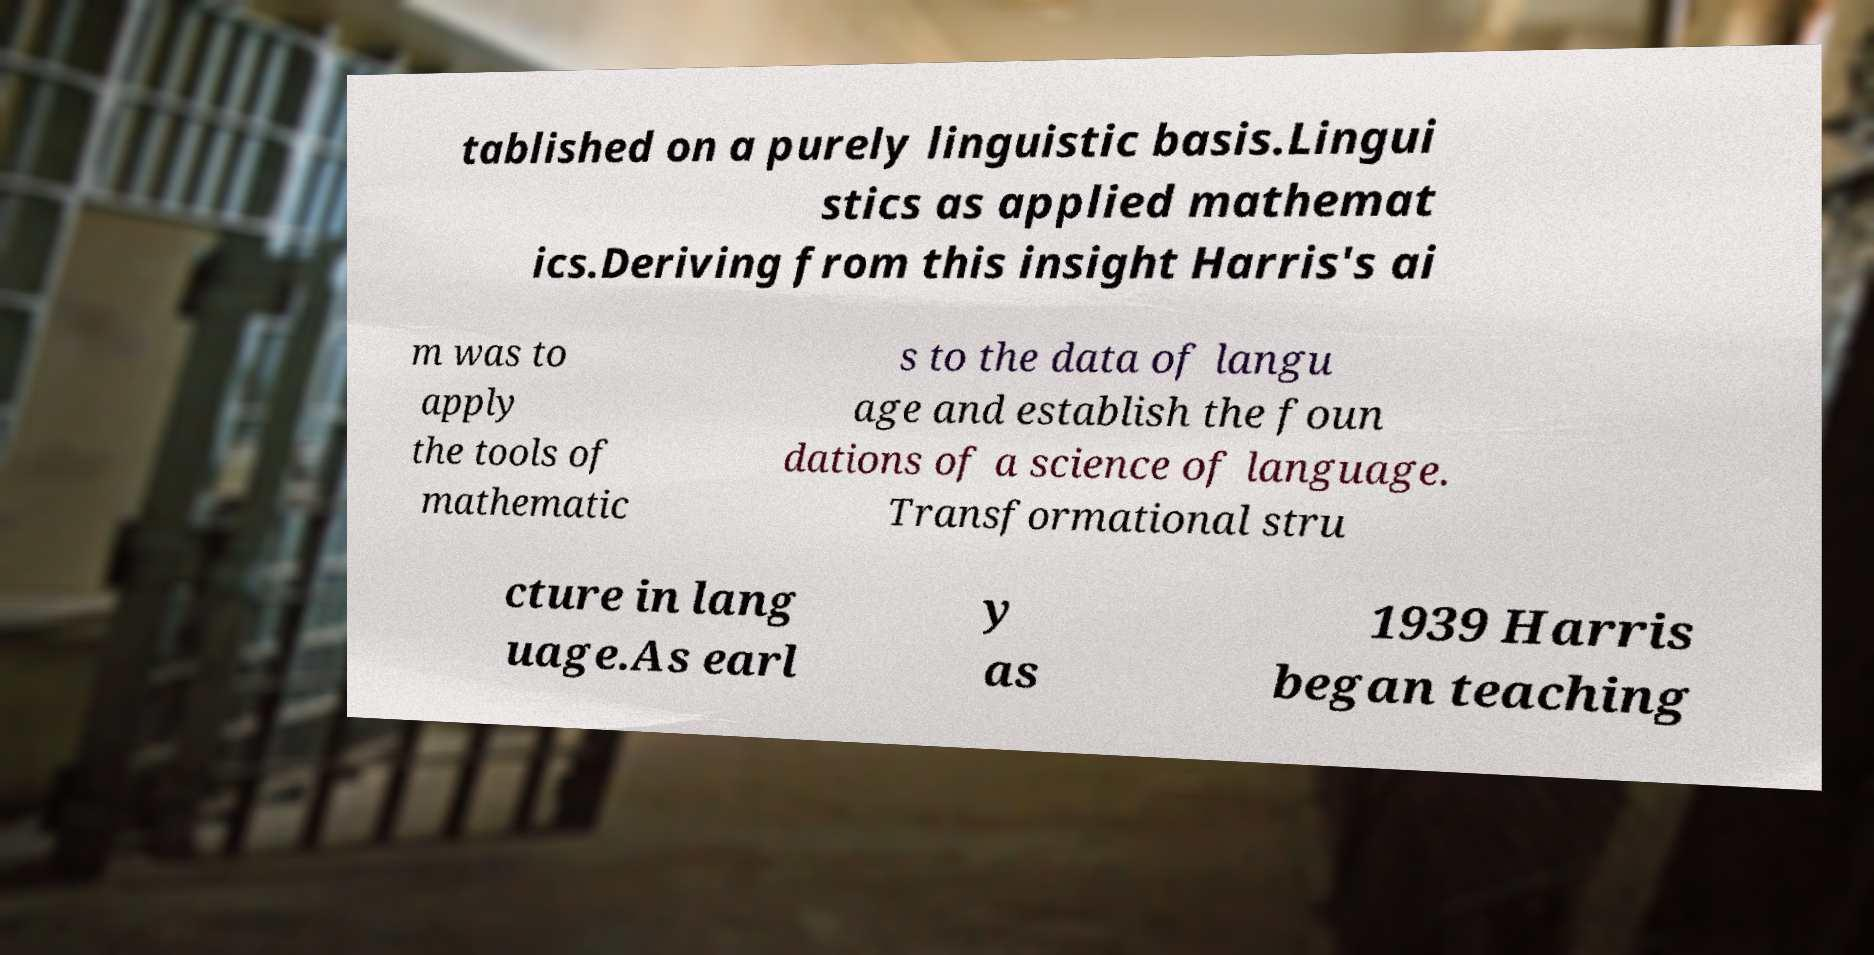Could you assist in decoding the text presented in this image and type it out clearly? tablished on a purely linguistic basis.Lingui stics as applied mathemat ics.Deriving from this insight Harris's ai m was to apply the tools of mathematic s to the data of langu age and establish the foun dations of a science of language. Transformational stru cture in lang uage.As earl y as 1939 Harris began teaching 